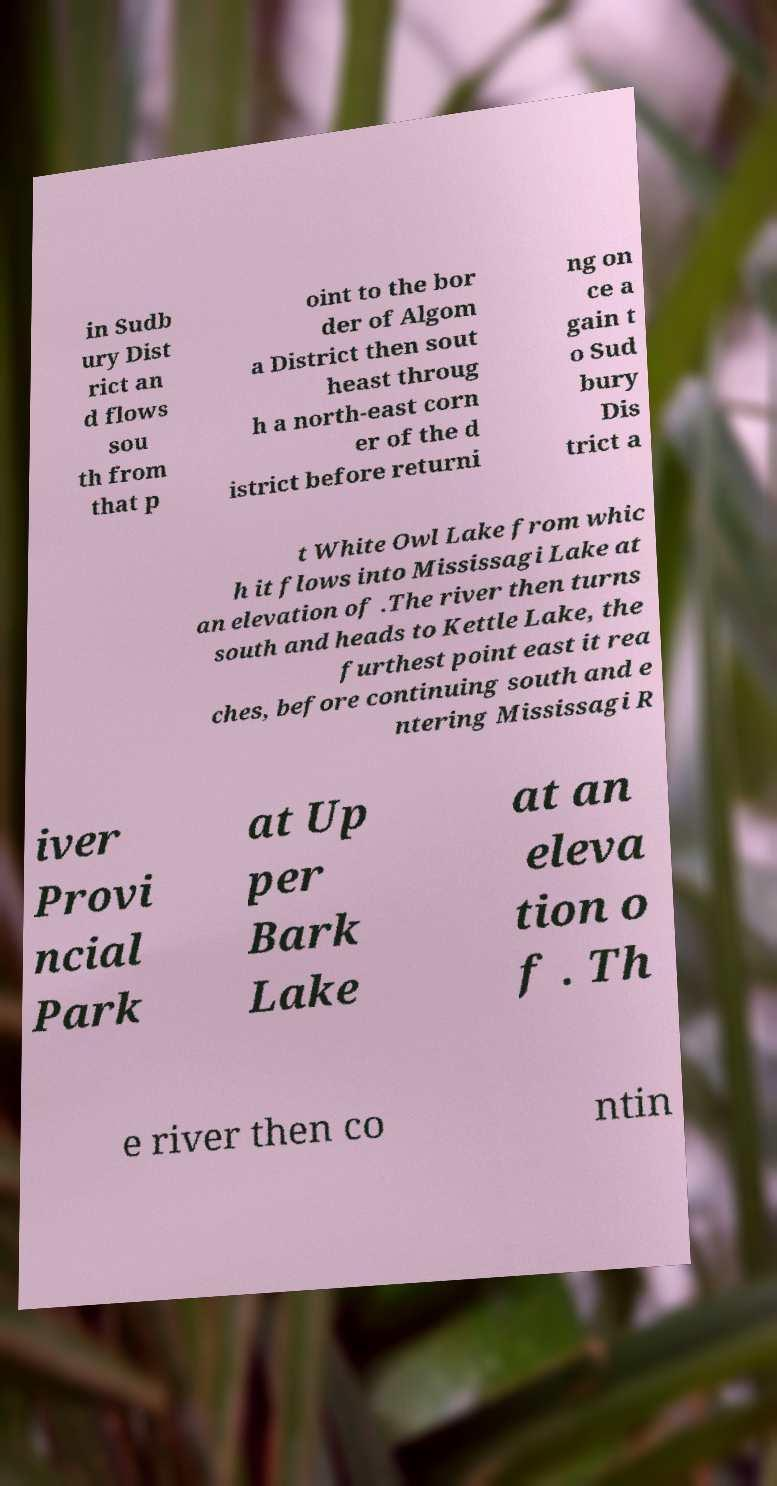What messages or text are displayed in this image? I need them in a readable, typed format. in Sudb ury Dist rict an d flows sou th from that p oint to the bor der of Algom a District then sout heast throug h a north-east corn er of the d istrict before returni ng on ce a gain t o Sud bury Dis trict a t White Owl Lake from whic h it flows into Mississagi Lake at an elevation of .The river then turns south and heads to Kettle Lake, the furthest point east it rea ches, before continuing south and e ntering Mississagi R iver Provi ncial Park at Up per Bark Lake at an eleva tion o f . Th e river then co ntin 